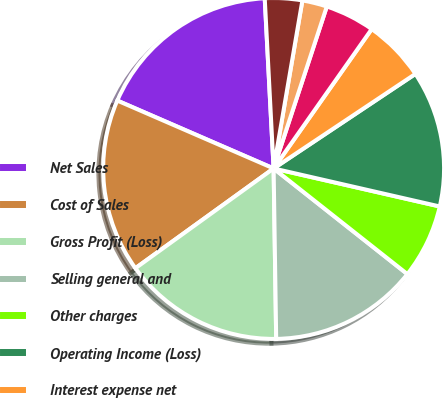Convert chart to OTSL. <chart><loc_0><loc_0><loc_500><loc_500><pie_chart><fcel>Net Sales<fcel>Cost of Sales<fcel>Gross Profit (Loss)<fcel>Selling general and<fcel>Other charges<fcel>Operating Income (Loss)<fcel>Interest expense net<fcel>Other net<fcel>Equity in net earnings of<fcel>Total Other (Income) Expense<nl><fcel>17.65%<fcel>16.47%<fcel>15.29%<fcel>14.12%<fcel>7.06%<fcel>12.94%<fcel>5.88%<fcel>4.71%<fcel>2.35%<fcel>3.53%<nl></chart> 